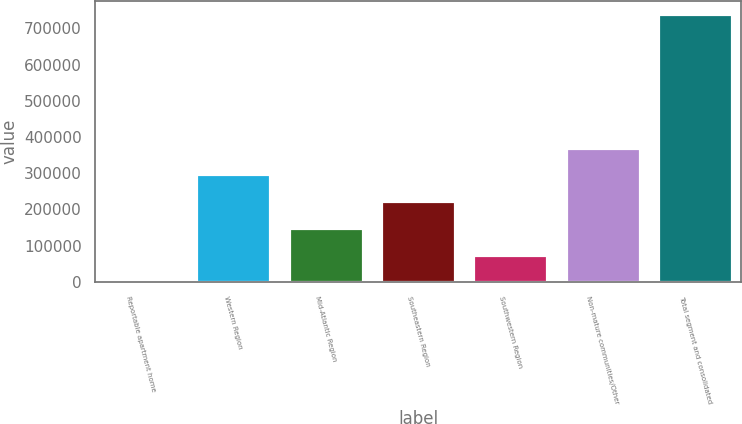<chart> <loc_0><loc_0><loc_500><loc_500><bar_chart><fcel>Reportable apartment home<fcel>Western Region<fcel>Mid-Atlantic Region<fcel>Southeastern Region<fcel>Southwestern Region<fcel>Non-mature communities/Other<fcel>Total segment and consolidated<nl><fcel>2007<fcel>296730<fcel>149368<fcel>223049<fcel>75687.7<fcel>370410<fcel>738814<nl></chart> 